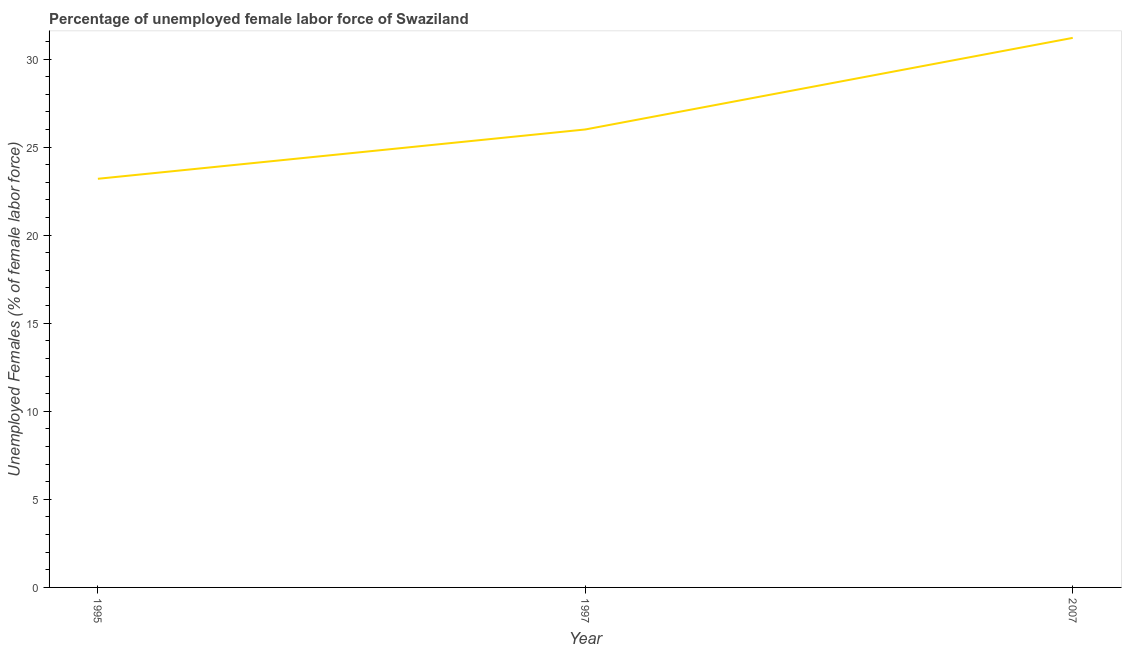What is the total unemployed female labour force in 2007?
Offer a very short reply. 31.2. Across all years, what is the maximum total unemployed female labour force?
Keep it short and to the point. 31.2. Across all years, what is the minimum total unemployed female labour force?
Offer a very short reply. 23.2. In which year was the total unemployed female labour force minimum?
Provide a short and direct response. 1995. What is the sum of the total unemployed female labour force?
Your answer should be compact. 80.4. What is the difference between the total unemployed female labour force in 1995 and 1997?
Your response must be concise. -2.8. What is the average total unemployed female labour force per year?
Offer a terse response. 26.8. Do a majority of the years between 1997 and 2007 (inclusive) have total unemployed female labour force greater than 15 %?
Offer a very short reply. Yes. What is the ratio of the total unemployed female labour force in 1997 to that in 2007?
Offer a terse response. 0.83. Is the total unemployed female labour force in 1995 less than that in 2007?
Your answer should be compact. Yes. What is the difference between the highest and the second highest total unemployed female labour force?
Your response must be concise. 5.2. In how many years, is the total unemployed female labour force greater than the average total unemployed female labour force taken over all years?
Make the answer very short. 1. Does the total unemployed female labour force monotonically increase over the years?
Give a very brief answer. Yes. How many lines are there?
Ensure brevity in your answer.  1. How many years are there in the graph?
Provide a succinct answer. 3. Does the graph contain grids?
Your answer should be compact. No. What is the title of the graph?
Ensure brevity in your answer.  Percentage of unemployed female labor force of Swaziland. What is the label or title of the X-axis?
Provide a short and direct response. Year. What is the label or title of the Y-axis?
Your answer should be compact. Unemployed Females (% of female labor force). What is the Unemployed Females (% of female labor force) of 1995?
Provide a succinct answer. 23.2. What is the Unemployed Females (% of female labor force) of 1997?
Your answer should be very brief. 26. What is the Unemployed Females (% of female labor force) of 2007?
Offer a terse response. 31.2. What is the difference between the Unemployed Females (% of female labor force) in 1997 and 2007?
Provide a short and direct response. -5.2. What is the ratio of the Unemployed Females (% of female labor force) in 1995 to that in 1997?
Give a very brief answer. 0.89. What is the ratio of the Unemployed Females (% of female labor force) in 1995 to that in 2007?
Keep it short and to the point. 0.74. What is the ratio of the Unemployed Females (% of female labor force) in 1997 to that in 2007?
Ensure brevity in your answer.  0.83. 